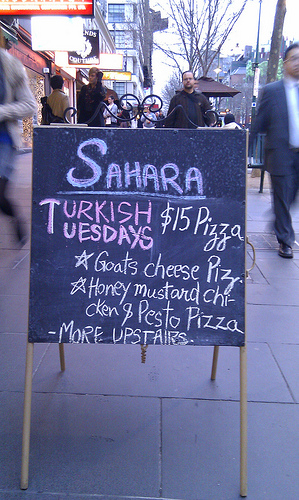<image>
Is there a person next to the sign? Yes. The person is positioned adjacent to the sign, located nearby in the same general area. Where is the sign board in relation to the man? Is it in front of the man? Yes. The sign board is positioned in front of the man, appearing closer to the camera viewpoint. 